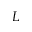Convert formula to latex. <formula><loc_0><loc_0><loc_500><loc_500>L</formula> 